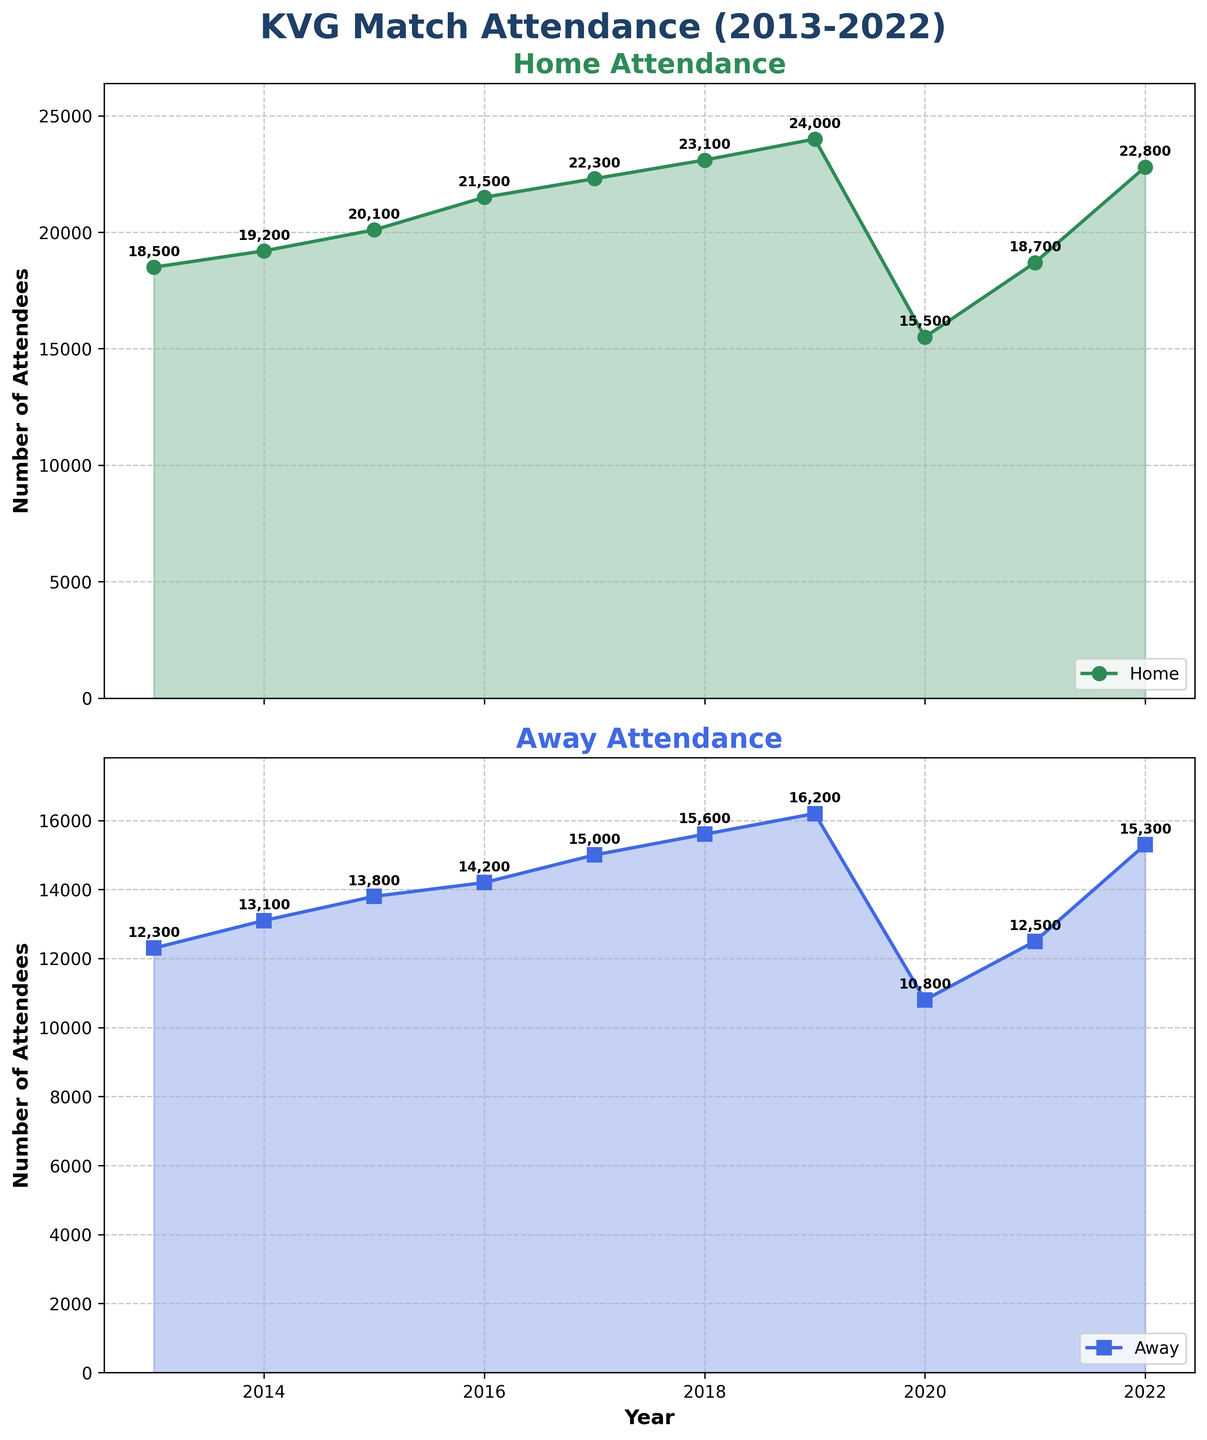How has home game attendance for KVG changed from 2013 to 2022? Review the home attendance subplot. Observe the line from 2013 to 2022 and note the overall trend.
Answer: It increased How did the away game attendance in 2020 compare to other years? Look at the away attendance subplot and find the data point for 2020. Compare this value with the other years.
Answer: It was the lowest What is the highest attendance recorded for KVG home games from 2013 to 2022? Check the peaks of the home attendance line on the subplot. Identify the year with the highest peak.
Answer: 24,000 in 2019 What is the percentage drop in home attendance from 2019 to 2020? Calculate the difference between the 2019 and 2020 attendance, divide by the 2019 attendance, and multiply by 100 to get the percentage decrease.
Answer: 35.4% Which year had nearly equal home and away attendance, and what were those numbers? Compare the home and away attendance values from each year by reviewing both subplots. Find the year where they were closest in value.
Answer: 2021, with 18,700 for home and 12,500 for away On average, how many more attendees were there for home games than away games over the decade? Calculate the difference between home and away attendance for each year, sum these differences, and divide by the number of years (10).
Answer: 6,400 In which year did both home and away attendance show the same trend, either increasing or decreasing? Identify years where both subplots lines either increased or decreased.
Answer: 2019 and 2020 What was the total home attendance for KVG between 2013 and 2022? Sum all the values on the home attendance subplot points.
Answer: 205,900 Which year saw the maximum increase in home attendance compared to the previous year? Calculate the year-on-year increase for each year in the home attendance subplot. Identify the maximum increase.
Answer: 2021 